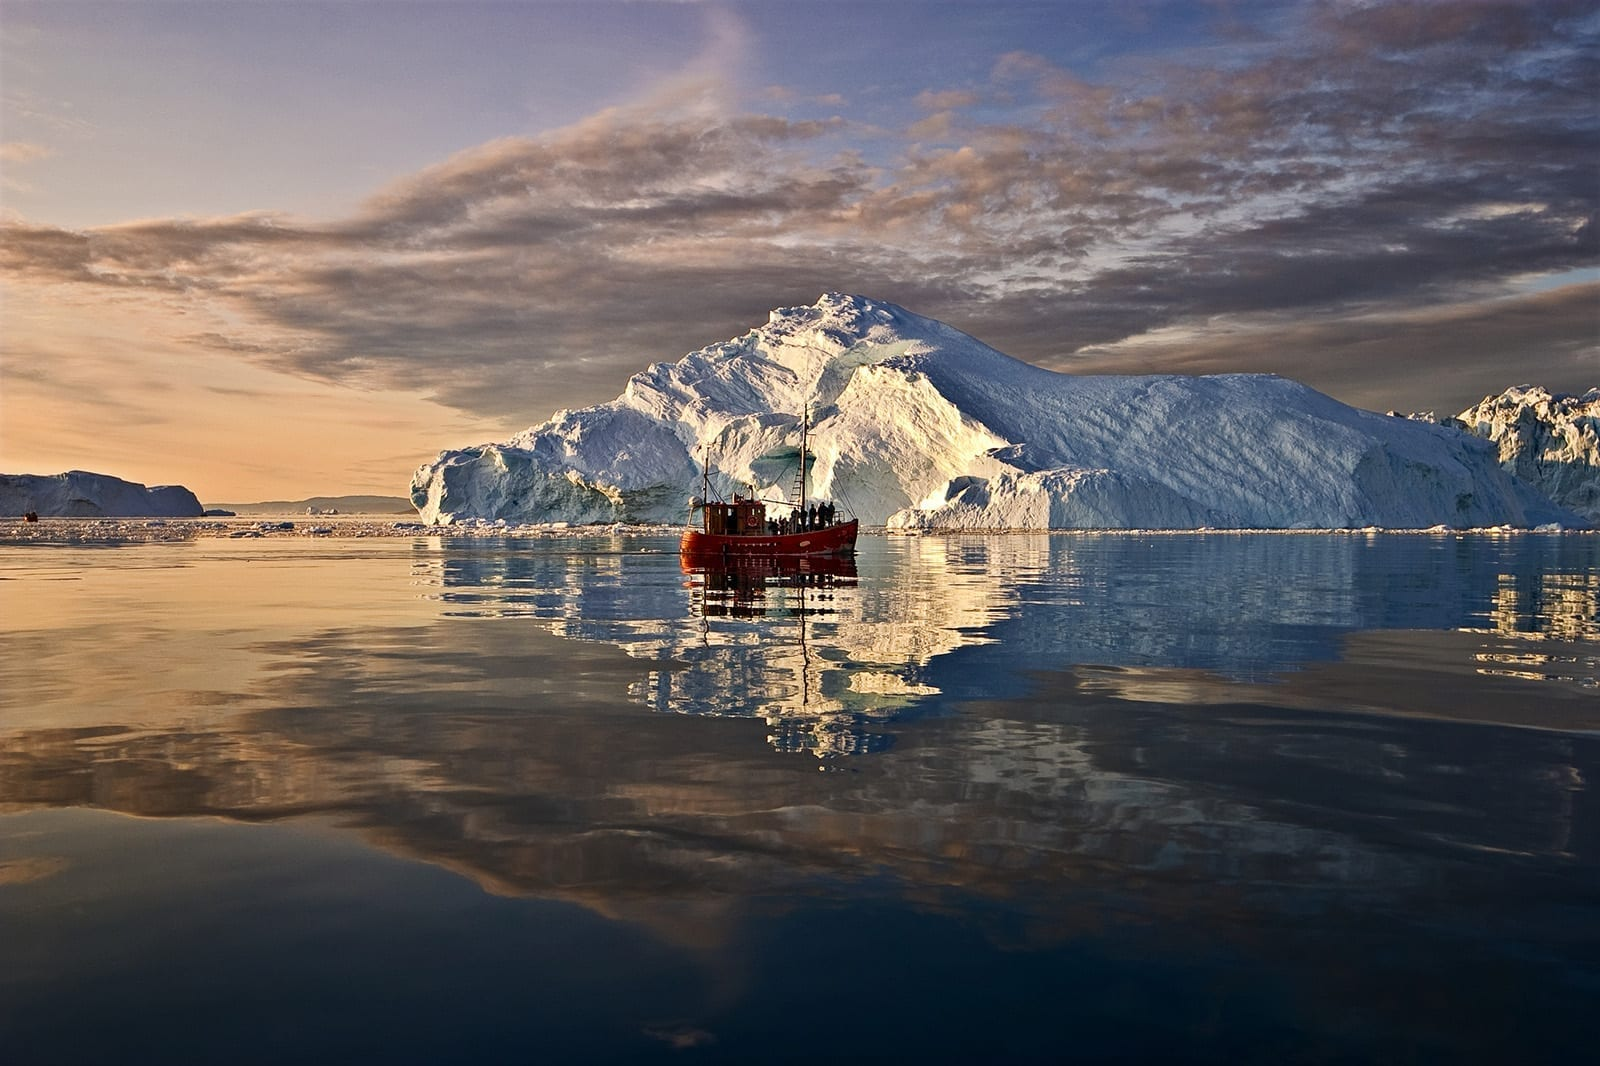What do you think is going on in this snapshot?
 The image captures the breathtaking view of the Ilulissat Icefjord, a UNESCO World Heritage Site located in Greenland. The perspective is from the water, facing towards the shore. The sky, painted in hues of orange and blue, is dotted with scattered clouds. The calm water below mirrors the sky and the towering icebergs around it. A red boat, appearing minuscule in comparison, is situated in the center of the frame, surrounded by the massive icebergs. These icebergs, glowing in the sunlight, exhibit a stunning palette of white and blue. The image beautifully encapsulates the grandeur and serene beauty of this world-renowned landmark. 